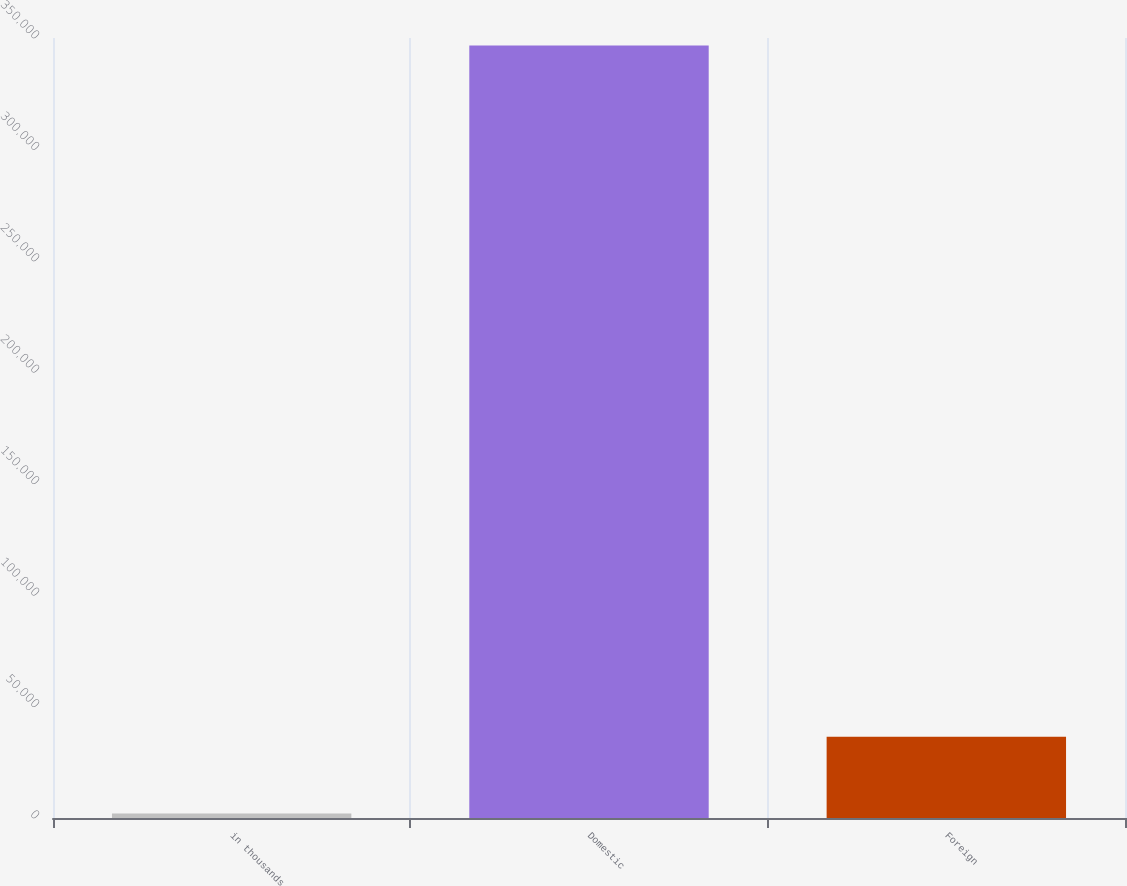Convert chart. <chart><loc_0><loc_0><loc_500><loc_500><bar_chart><fcel>in thousands<fcel>Domestic<fcel>Foreign<nl><fcel>2017<fcel>346668<fcel>36482.1<nl></chart> 